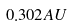<formula> <loc_0><loc_0><loc_500><loc_500>0 . 3 0 2 { A U }</formula> 